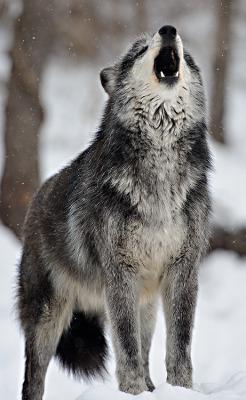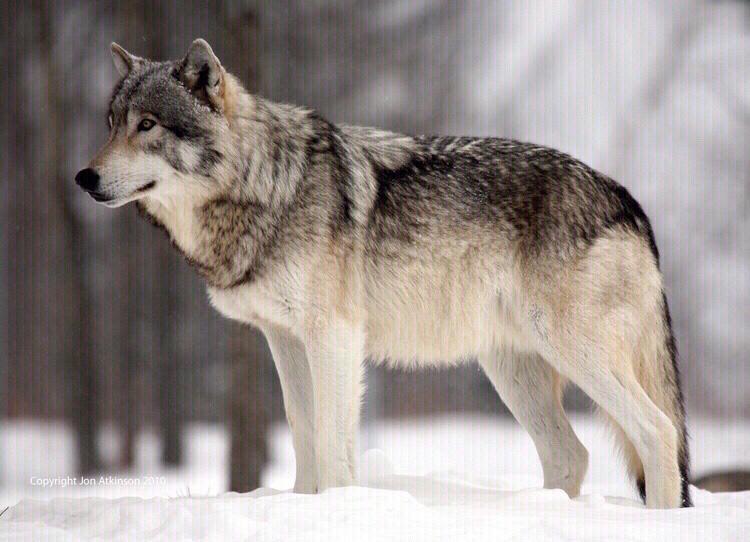The first image is the image on the left, the second image is the image on the right. Analyze the images presented: Is the assertion "There are no more than two wolves standing outside." valid? Answer yes or no. Yes. 